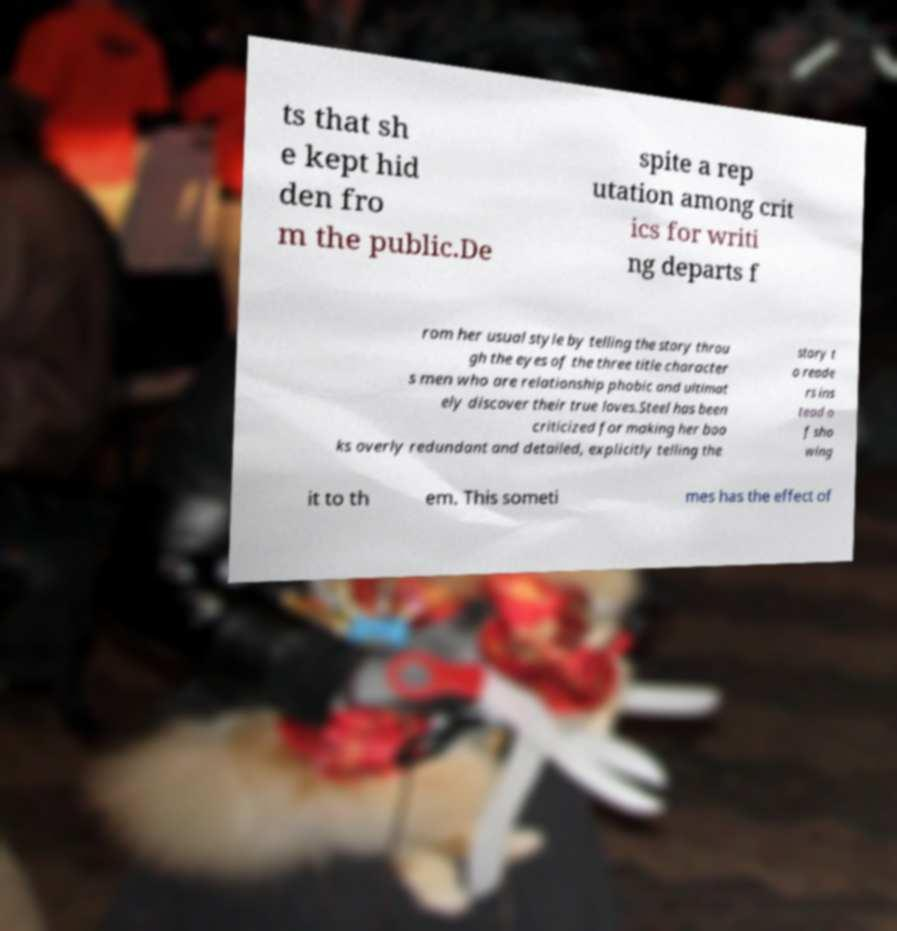Please identify and transcribe the text found in this image. ts that sh e kept hid den fro m the public.De spite a rep utation among crit ics for writi ng departs f rom her usual style by telling the story throu gh the eyes of the three title character s men who are relationship phobic and ultimat ely discover their true loves.Steel has been criticized for making her boo ks overly redundant and detailed, explicitly telling the story t o reade rs ins tead o f sho wing it to th em. This someti mes has the effect of 